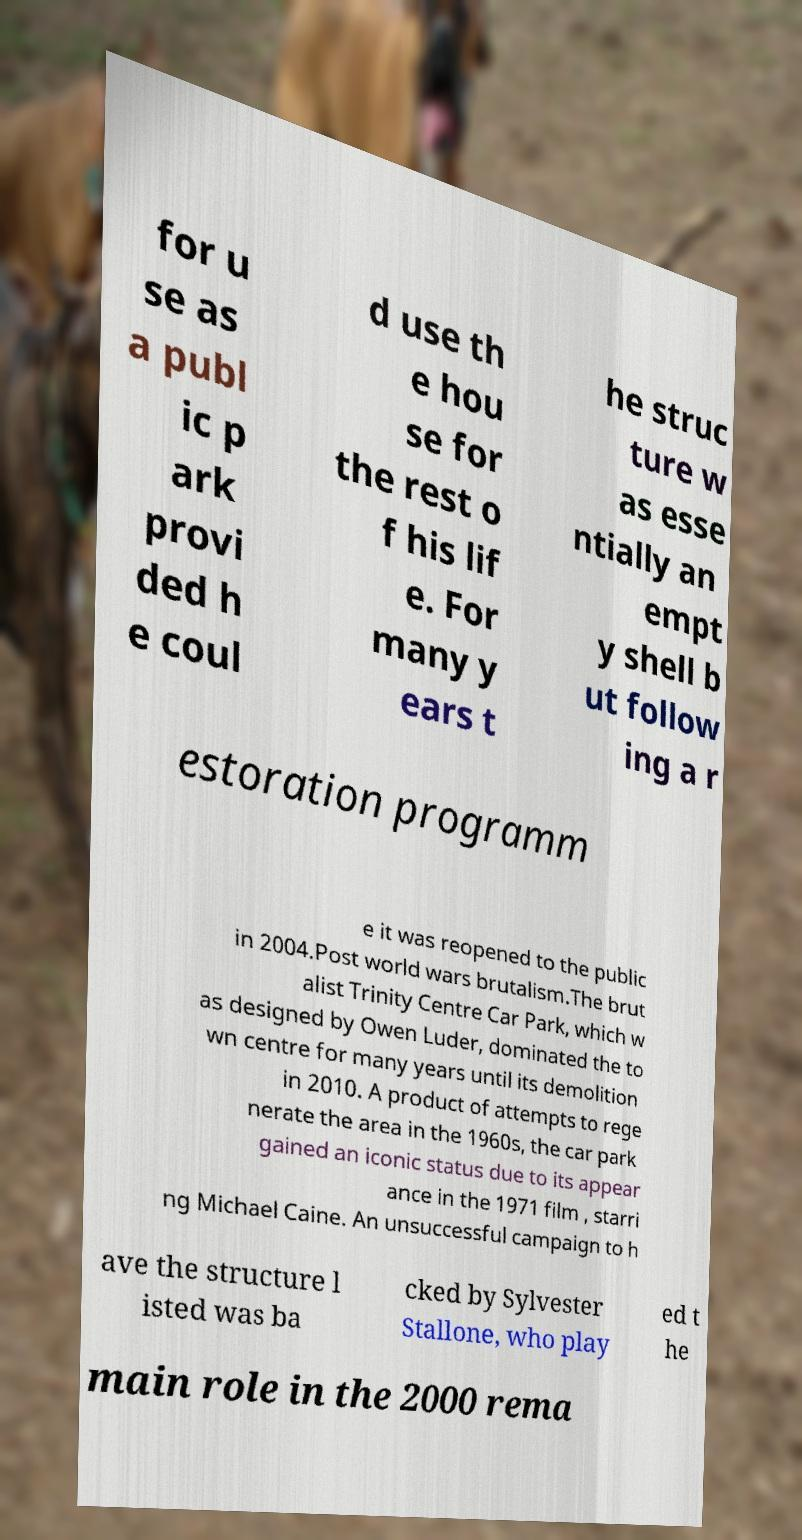Please identify and transcribe the text found in this image. for u se as a publ ic p ark provi ded h e coul d use th e hou se for the rest o f his lif e. For many y ears t he struc ture w as esse ntially an empt y shell b ut follow ing a r estoration programm e it was reopened to the public in 2004.Post world wars brutalism.The brut alist Trinity Centre Car Park, which w as designed by Owen Luder, dominated the to wn centre for many years until its demolition in 2010. A product of attempts to rege nerate the area in the 1960s, the car park gained an iconic status due to its appear ance in the 1971 film , starri ng Michael Caine. An unsuccessful campaign to h ave the structure l isted was ba cked by Sylvester Stallone, who play ed t he main role in the 2000 rema 